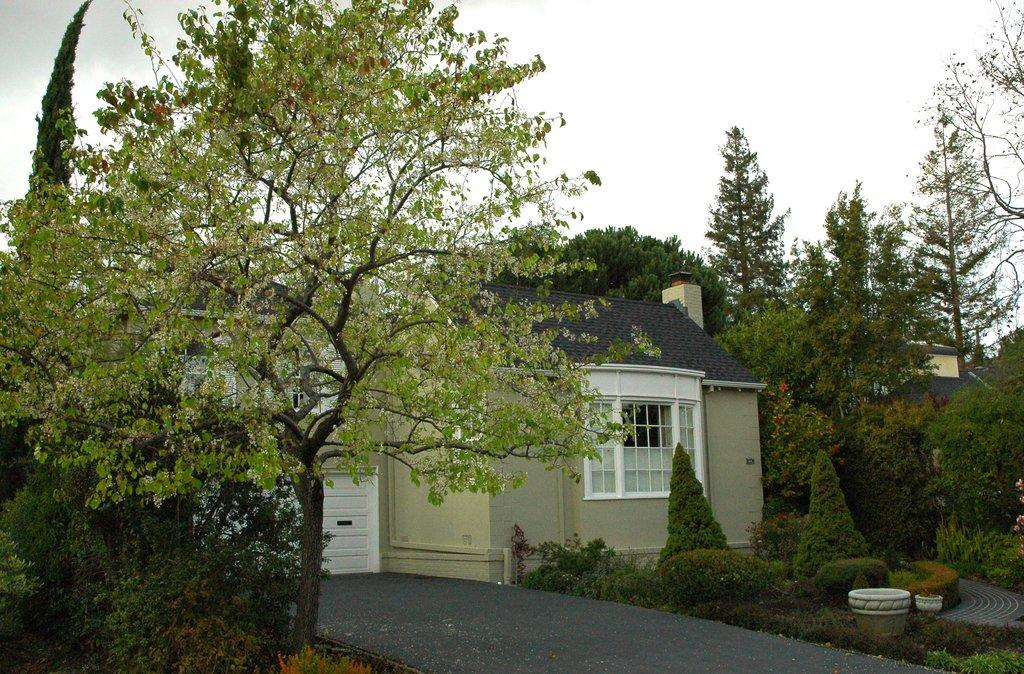What type of structures can be seen in the image? There are houses in the image. What colors are the houses? The houses are in white and cream colors. What other natural elements are present in the image? There are trees in the image. What is the color of the trees? The trees are green. What part of the natural environment is visible in the image? The sky is visible in the image. What is the color of the sky? The sky is in white color. Can you tell me how many corn plants are growing in the image? There are no corn plants present in the image. What type of plantation can be seen in the image? There is no plantation present in the image. 